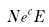<formula> <loc_0><loc_0><loc_500><loc_500>N e ^ { c } E</formula> 